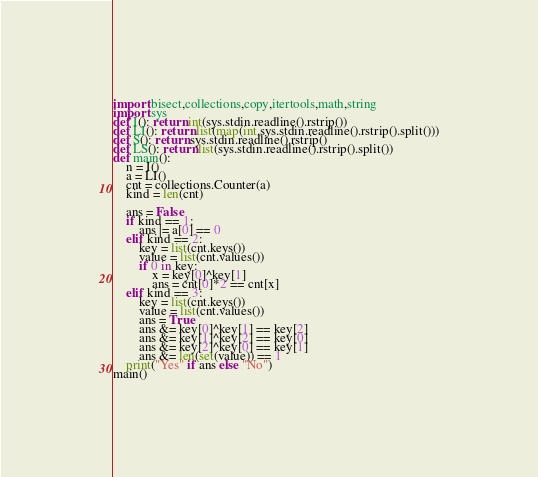Convert code to text. <code><loc_0><loc_0><loc_500><loc_500><_Python_>import bisect,collections,copy,itertools,math,string
import sys
def I(): return int(sys.stdin.readline().rstrip())
def LI(): return list(map(int,sys.stdin.readline().rstrip().split()))
def S(): return sys.stdin.readline().rstrip()
def LS(): return list(sys.stdin.readline().rstrip().split())
def main():
    n = I()
    a = LI()
    cnt = collections.Counter(a)
    kind = len(cnt)

    ans = False
    if kind == 1:
        ans |= a[0] == 0
    elif kind == 2:
        key = list(cnt.keys())
        value = list(cnt.values())
        if 0 in key:
            x = key[0]^key[1]
            ans = cnt[0]*2 == cnt[x]
    elif kind == 3:
        key = list(cnt.keys())
        value = list(cnt.values())
        ans = True
        ans &= key[0]^key[1] == key[2]
        ans &= key[1]^key[2] == key[0]
        ans &= key[2]^key[0] == key[1]
        ans &= len(set(value)) == 1
    print("Yes" if ans else "No")
main()
</code> 